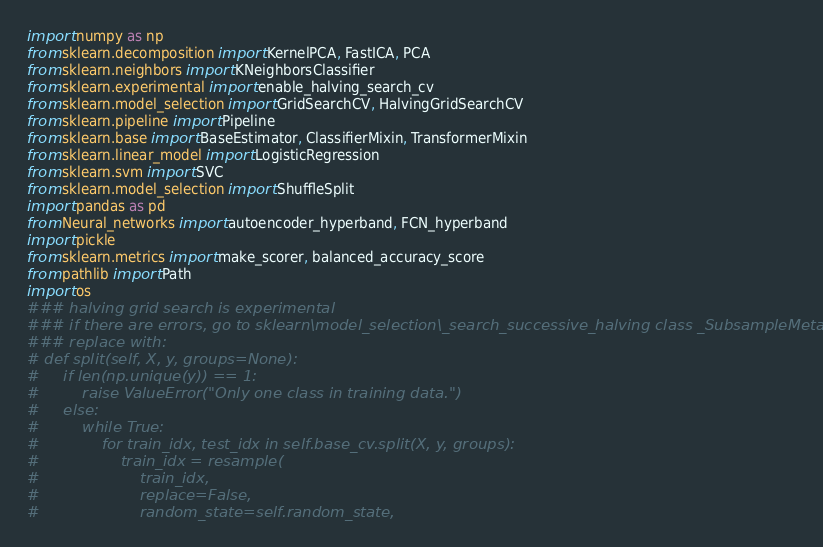Convert code to text. <code><loc_0><loc_0><loc_500><loc_500><_Python_>import numpy as np
from sklearn.decomposition import KernelPCA, FastICA, PCA
from sklearn.neighbors import KNeighborsClassifier
from sklearn.experimental import enable_halving_search_cv
from sklearn.model_selection import GridSearchCV, HalvingGridSearchCV
from sklearn.pipeline import Pipeline
from sklearn.base import BaseEstimator, ClassifierMixin, TransformerMixin
from sklearn.linear_model import LogisticRegression
from sklearn.svm import SVC
from sklearn.model_selection import ShuffleSplit
import pandas as pd
from Neural_networks import autoencoder_hyperband, FCN_hyperband
import pickle
from sklearn.metrics import make_scorer, balanced_accuracy_score
from pathlib import Path
import os
### halving grid search is experimental
### if there are errors, go to sklearn\model_selection\_search_successive_halving class _SubsampleMetaSplitter:
### replace with:
# def split(self, X, y, groups=None):
#     if len(np.unique(y)) == 1:
#         raise ValueError("Only one class in training data.")
#     else:
#         while True:
#             for train_idx, test_idx in self.base_cv.split(X, y, groups):
#                 train_idx = resample(
#                     train_idx,
#                     replace=False,
#                     random_state=self.random_state,</code> 